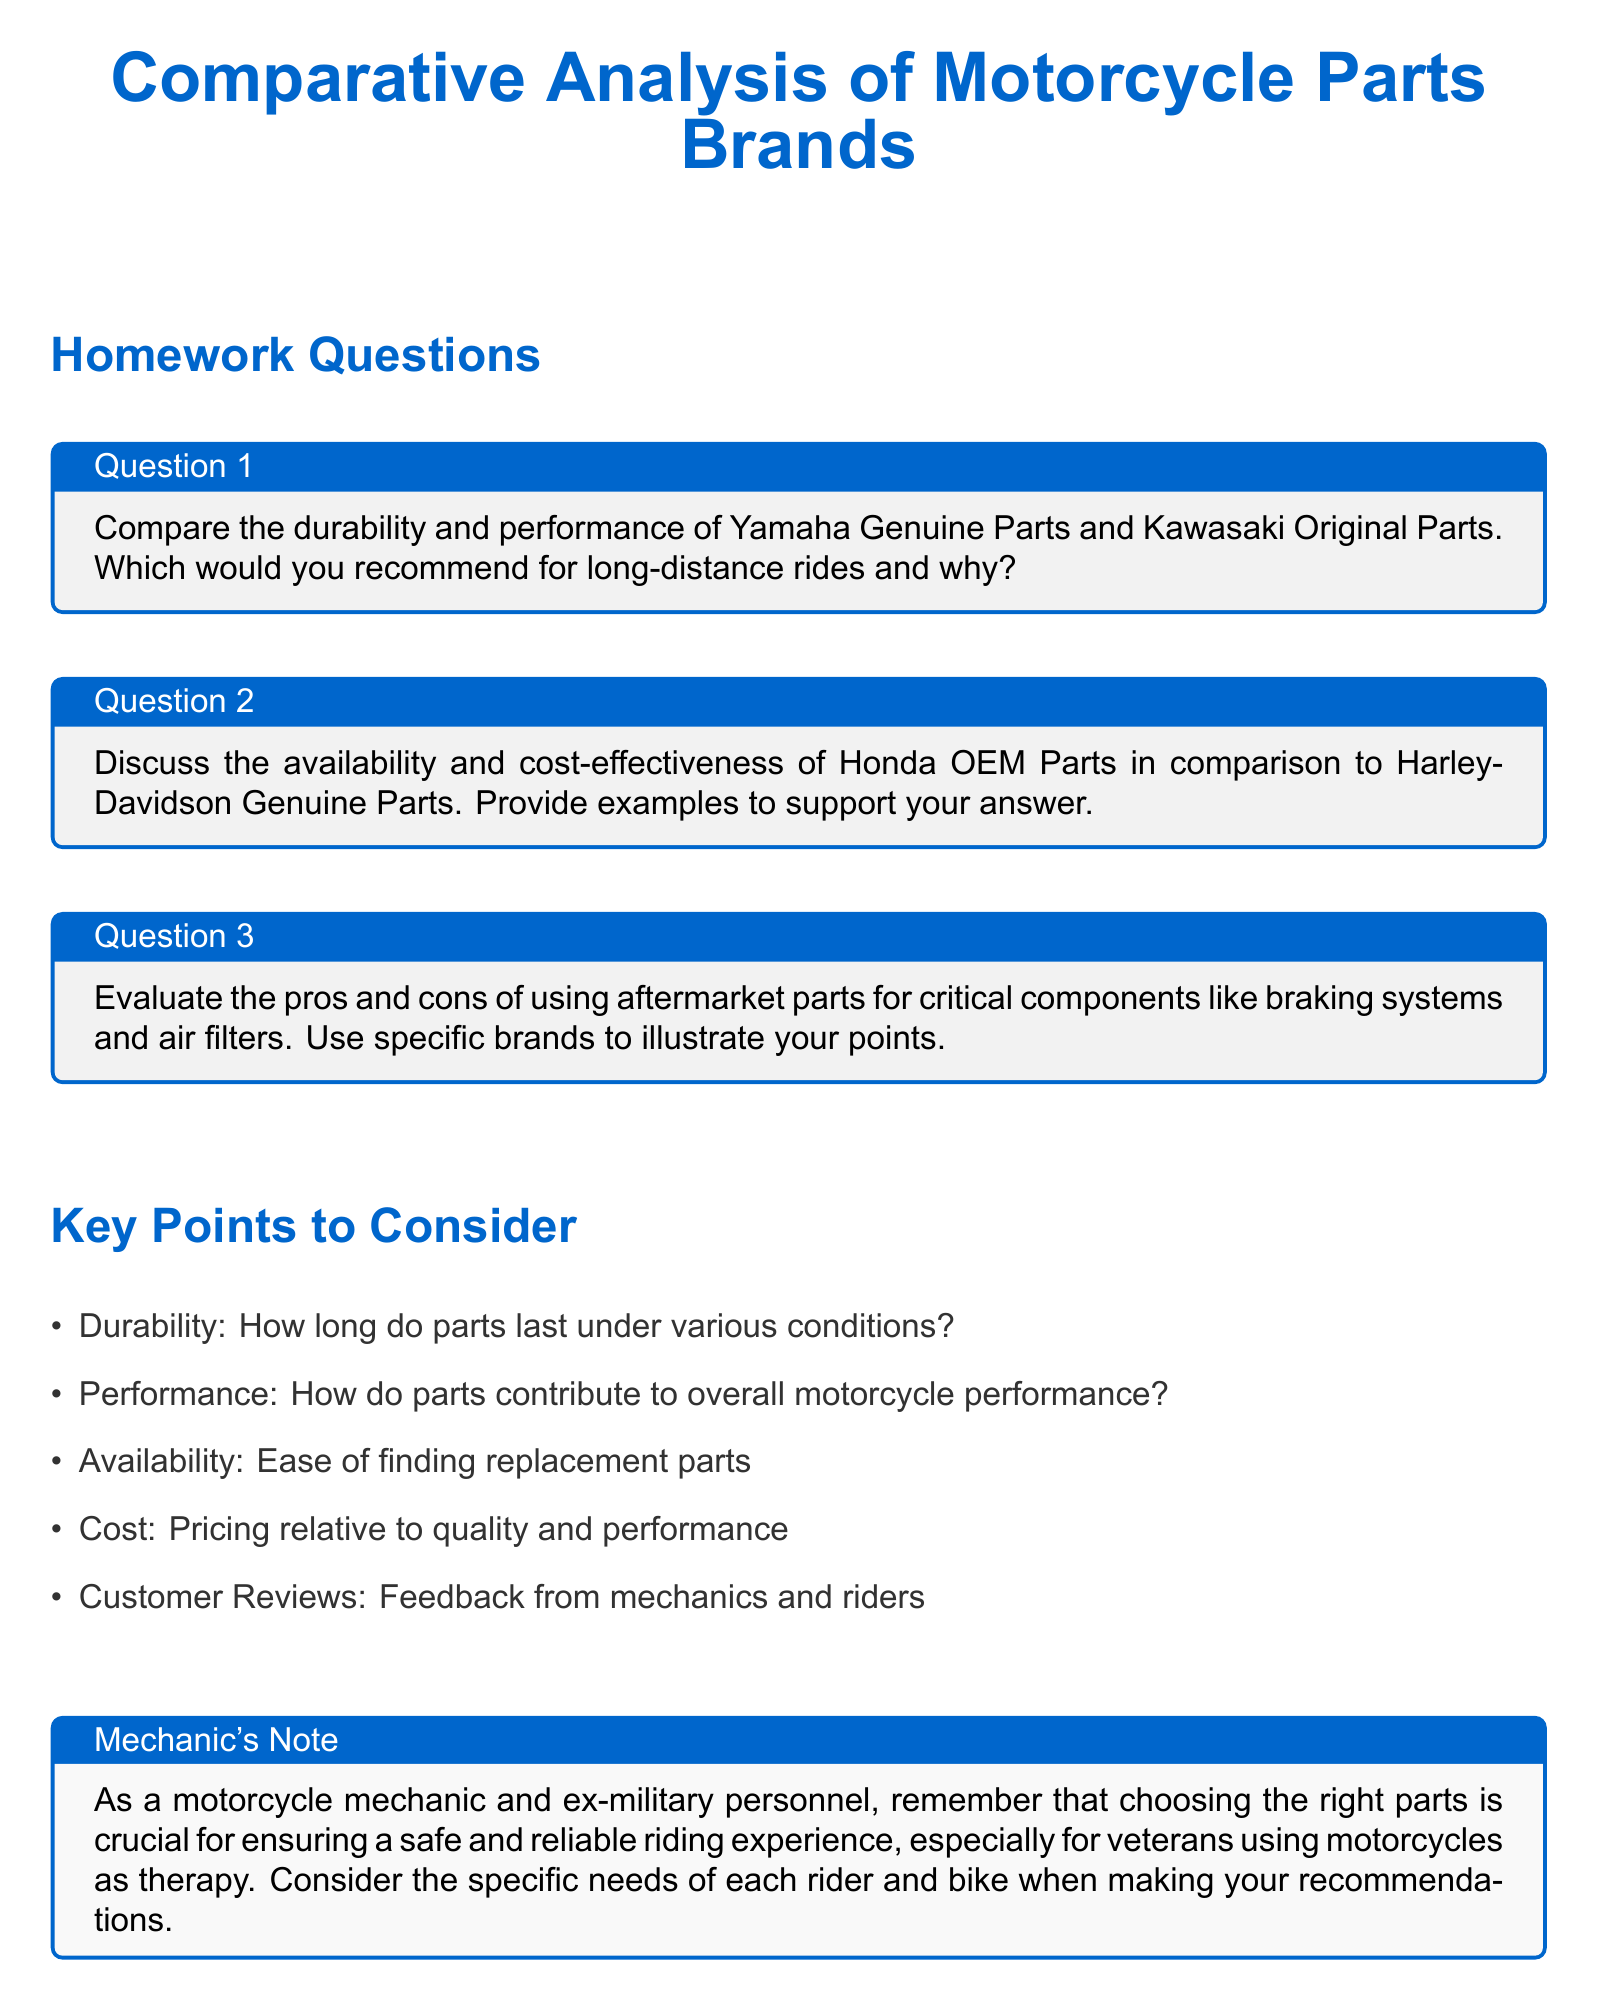What is the title of the document? The title of the document is included at the top center of the page, stating the focus of the homework.
Answer: Comparative Analysis of Motorcycle Parts Brands What is the color of the document's main text? The color of the main text is specified in the document as motorcyclegray.
Answer: motorcyclegray Which two brands are compared for durability and performance? The specific brands mentioned for comparison in Question 1 are Yamaha and Kawasaki.
Answer: Yamaha and Kawasaki What type of parts does Question 2 focus on? Question 2 discusses a specific type of parts that are original to their respective manufacturers, which affects availability and pricing.
Answer: OEM Parts What is a key point to consider regarding motorcycle parts? The document lists key considerations related to evaluating motorcycle parts, which includes several factors influencing part selection.
Answer: Durability How many questions are included in the homework? The document outlines a total of three specific questions that need to be addressed with answers.
Answer: Three What occupation does the document refer to in the Mechanic's Note? The note highlights the experience and perspective of the person involved in motorcycle repairs and veteran support.
Answer: mechanic What is the primary focus of the Comparative Analysis? The analysis aims to evaluate different brands of motorcycle parts based on specific criteria such as performance and cost.
Answer: Motorcycle Parts Brands 